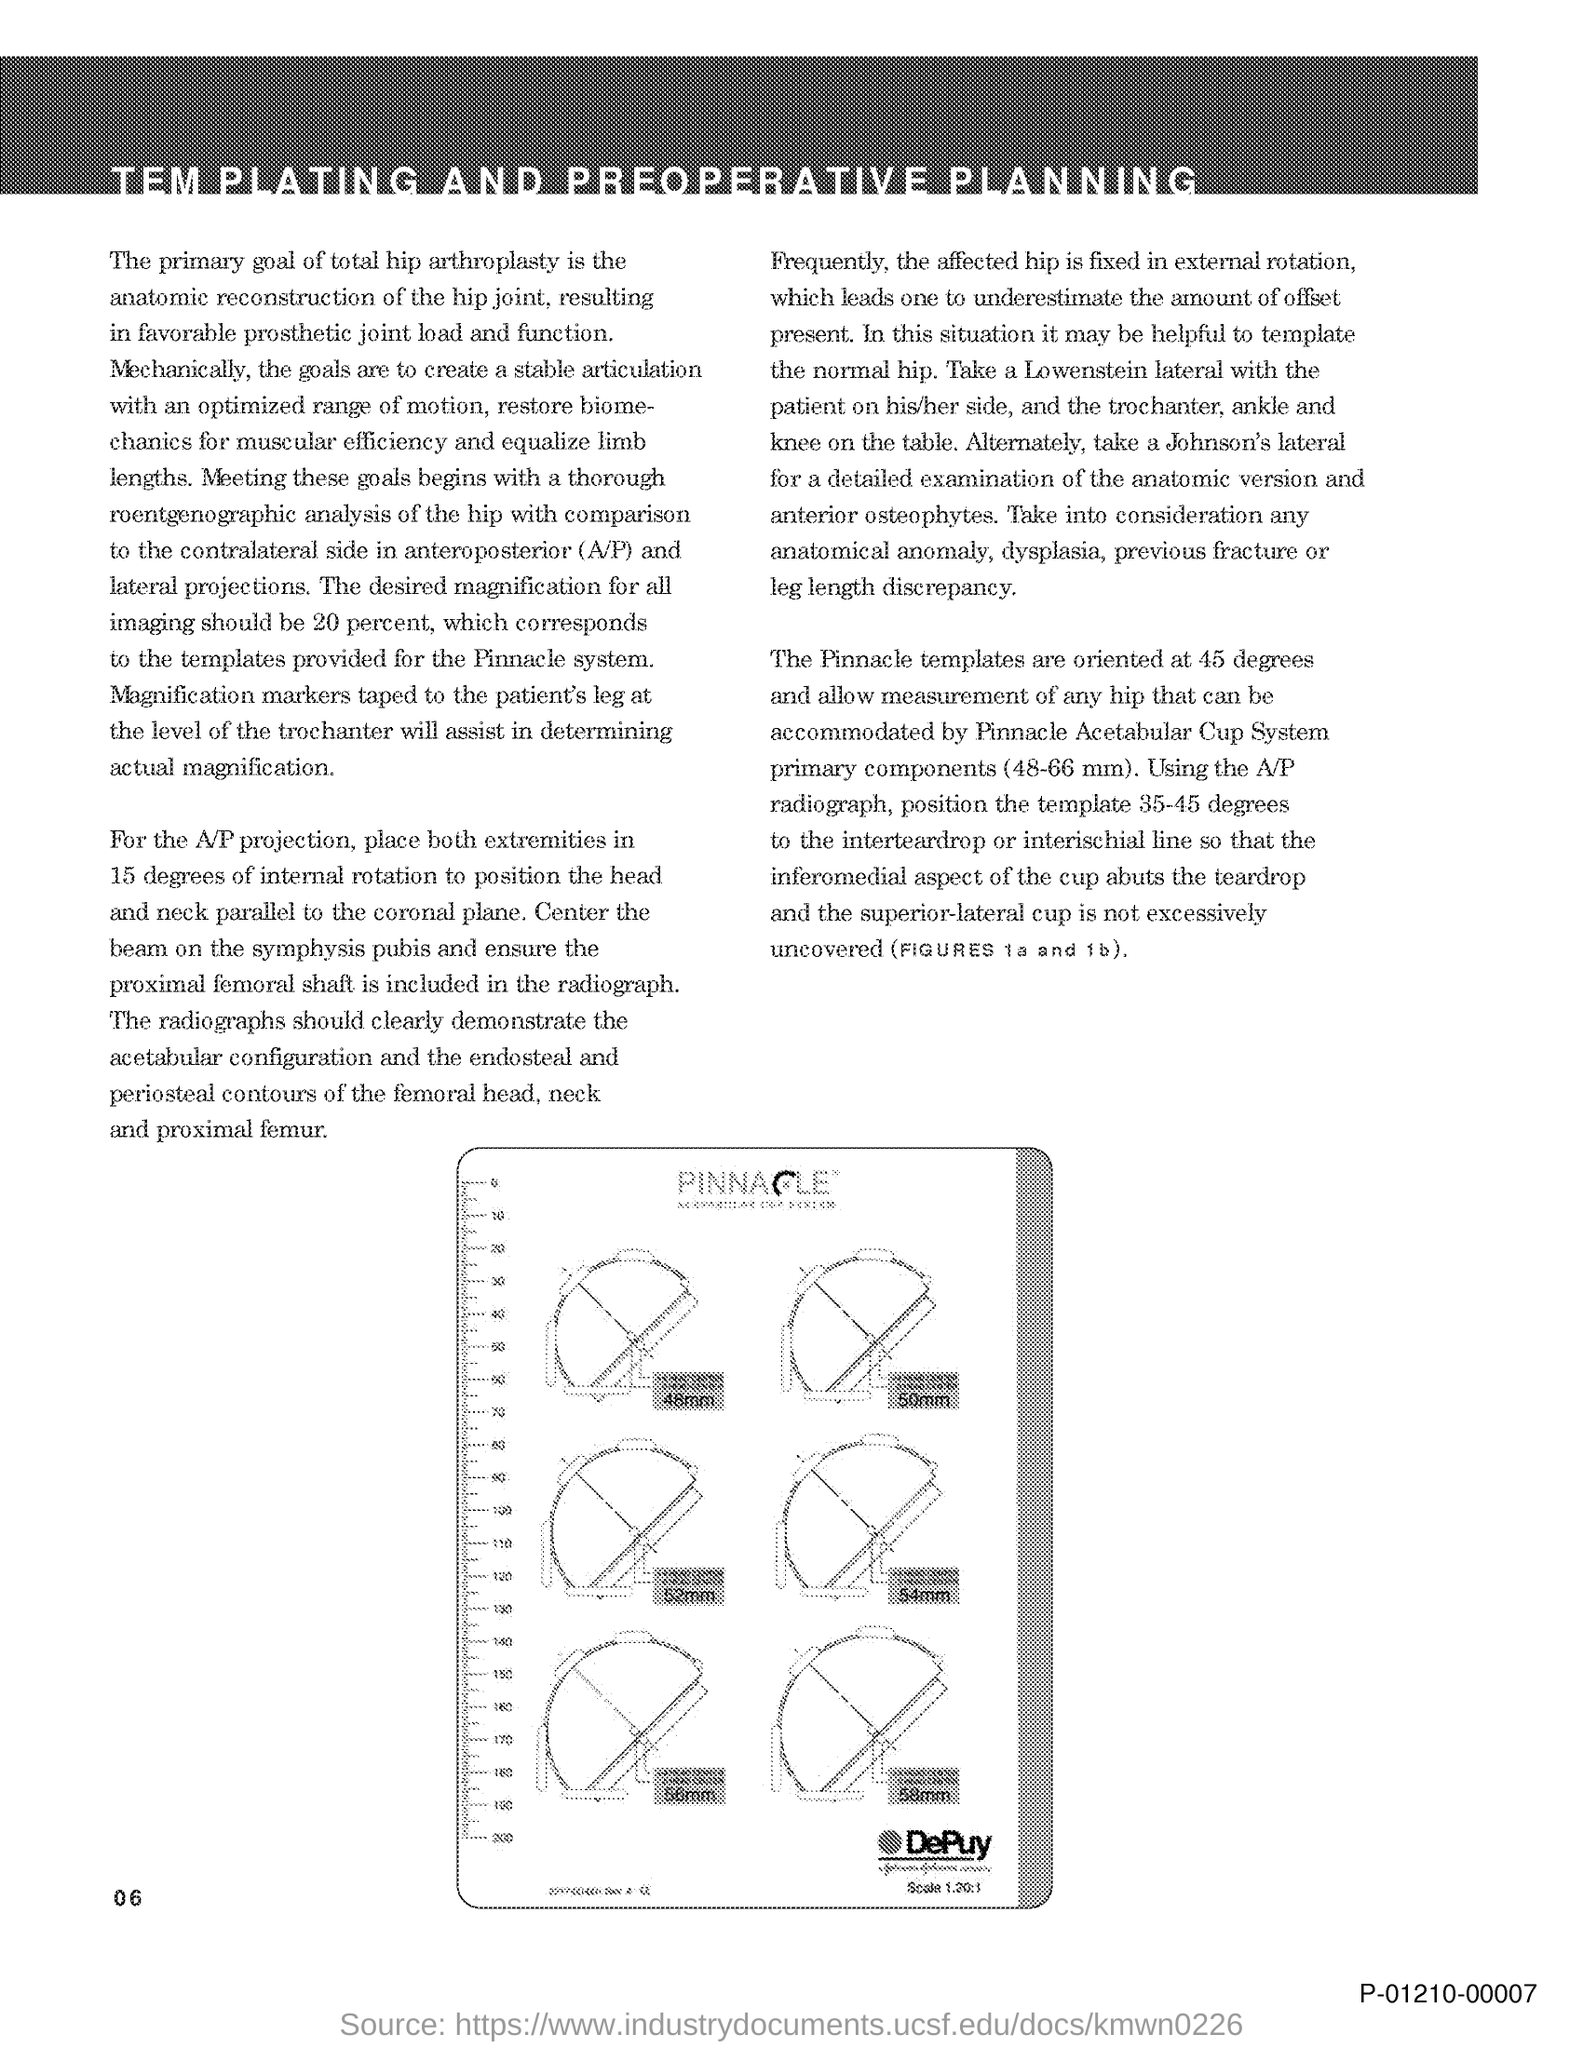Draw attention to some important aspects in this diagram. The pinnacle templates are oriented at an angle of 45 degrees. 